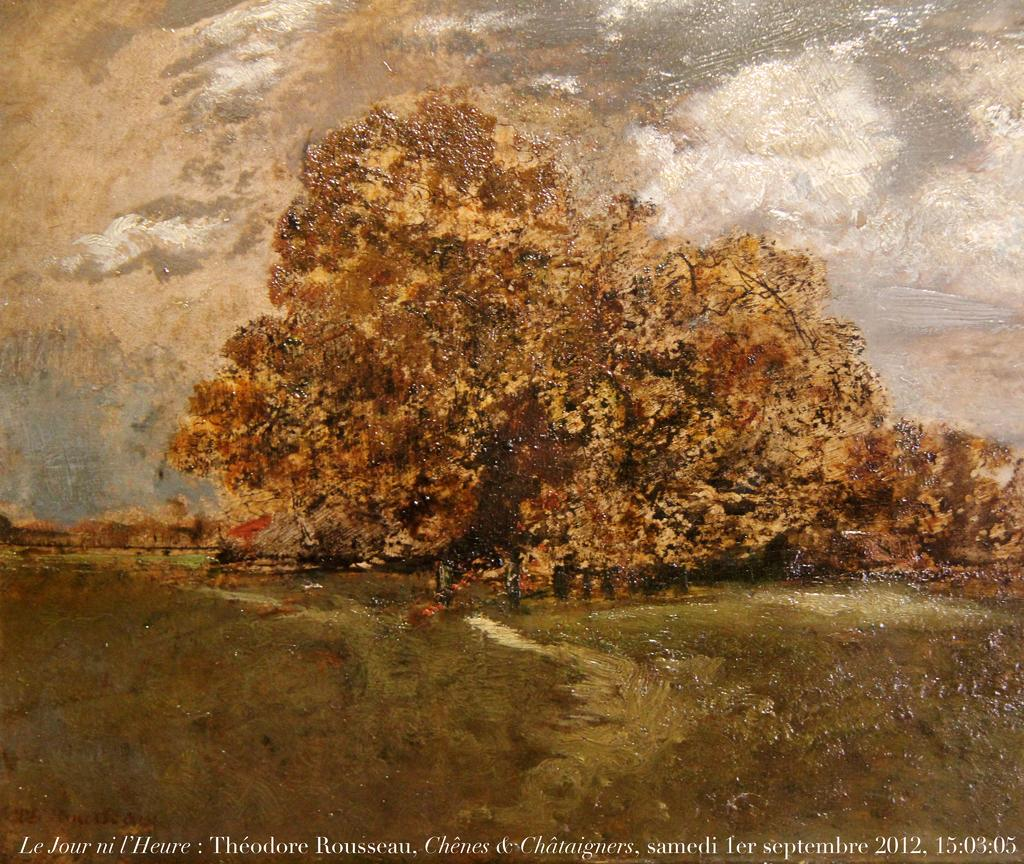What type of artwork is depicted in the image? The image is a painting. What natural elements can be seen in the painting? There are trees and clouds in the sky in the painting. Is there any text present in the painting? Yes, there is text written at the bottom of the painting. What type of song is being sung by the crowd in the painting? There is no crowd or song present in the painting; it features trees, clouds, and text. 